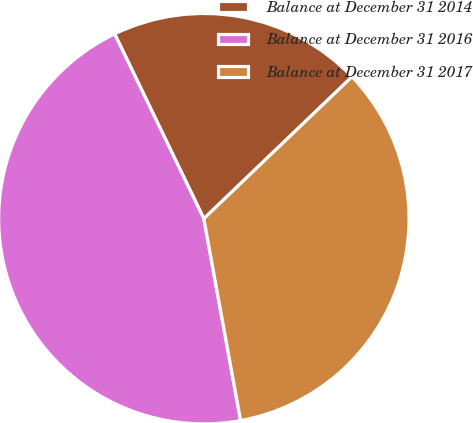Convert chart. <chart><loc_0><loc_0><loc_500><loc_500><pie_chart><fcel>Balance at December 31 2014<fcel>Balance at December 31 2016<fcel>Balance at December 31 2017<nl><fcel>20.0%<fcel>45.71%<fcel>34.29%<nl></chart> 